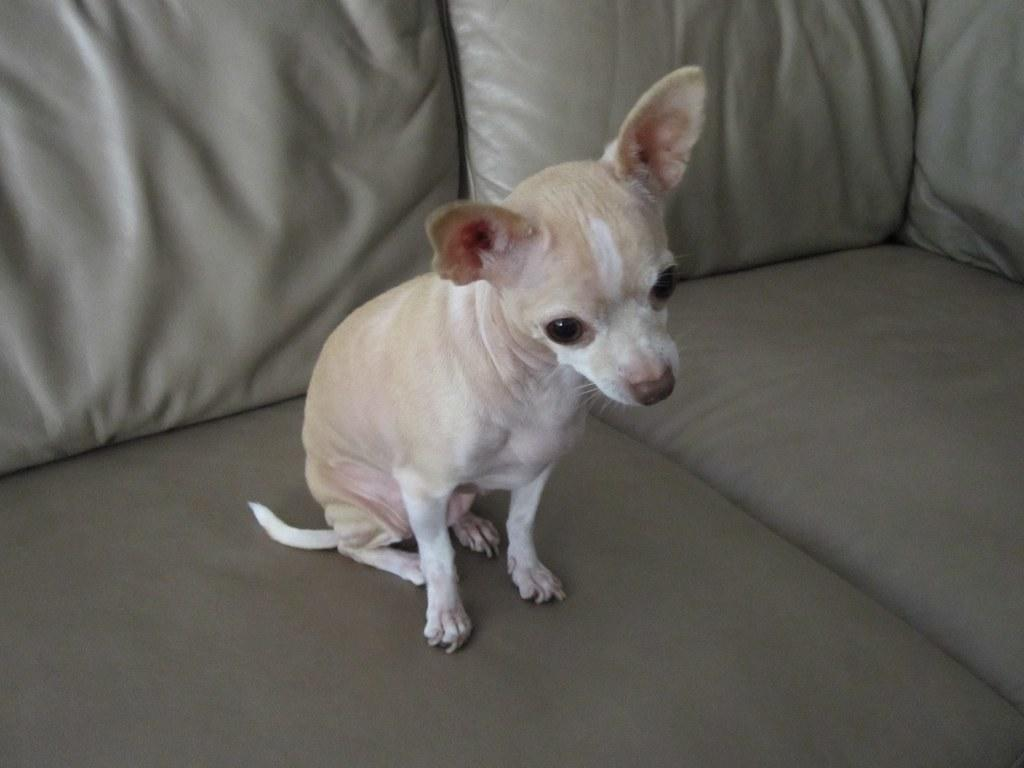What type of animal is present in the image? There is a dog in the image. What is the dog doing in the image? The dog is sitting on a sofa. What type of popcorn is the dog eating in the image? There is no popcorn present in the image. How many cows are visible in the image? There are no cows visible in the image. What type of jeans is the dog wearing in the image? Dogs do not wear jeans, and there is no mention of the dog wearing any clothing in the image. 